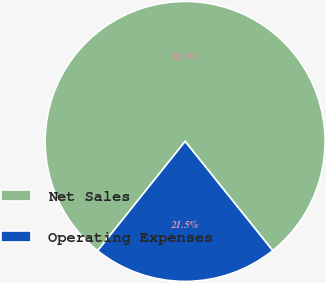Convert chart to OTSL. <chart><loc_0><loc_0><loc_500><loc_500><pie_chart><fcel>Net Sales<fcel>Operating Expenses<nl><fcel>78.5%<fcel>21.5%<nl></chart> 